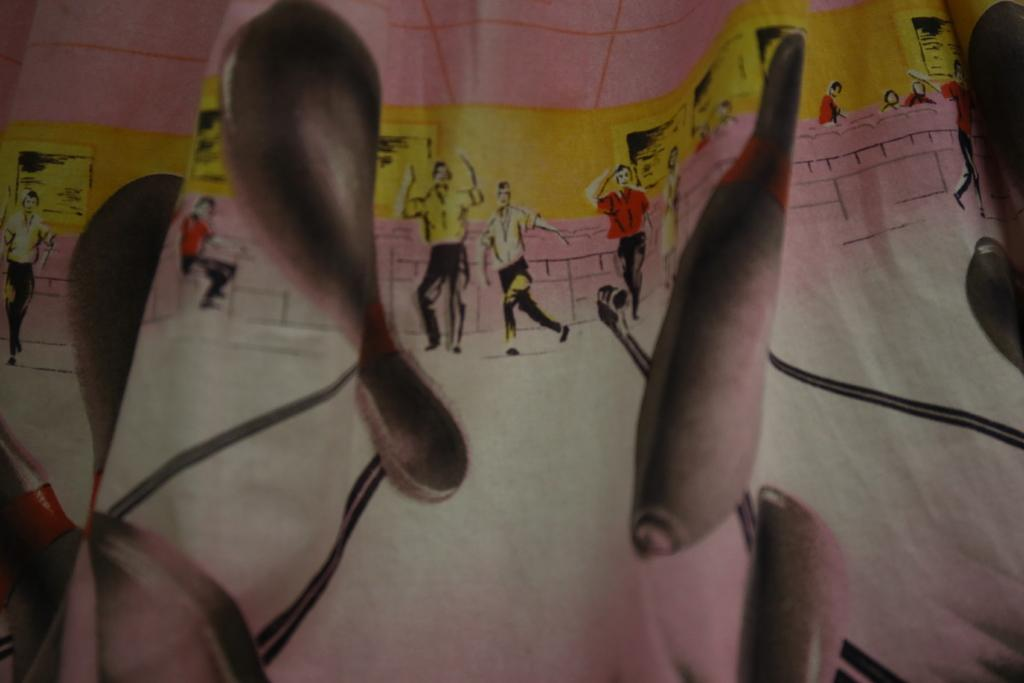What is the main object in the image? There is a cloth in the image. What can be seen on the cloth? The cloth has a print of pictures on it, including toy bowling, persons, and chairs. Are there any other objects or features in the image? Yes, there are charts on the wall in the image. Can you tell me how many guitars are being played in the image? There are no guitars present in the image; the cloth features pictures of toy bowling, persons, and chairs. What type of road can be seen in the image? There is no road visible in the image; it features a cloth with pictures and charts on the wall. 